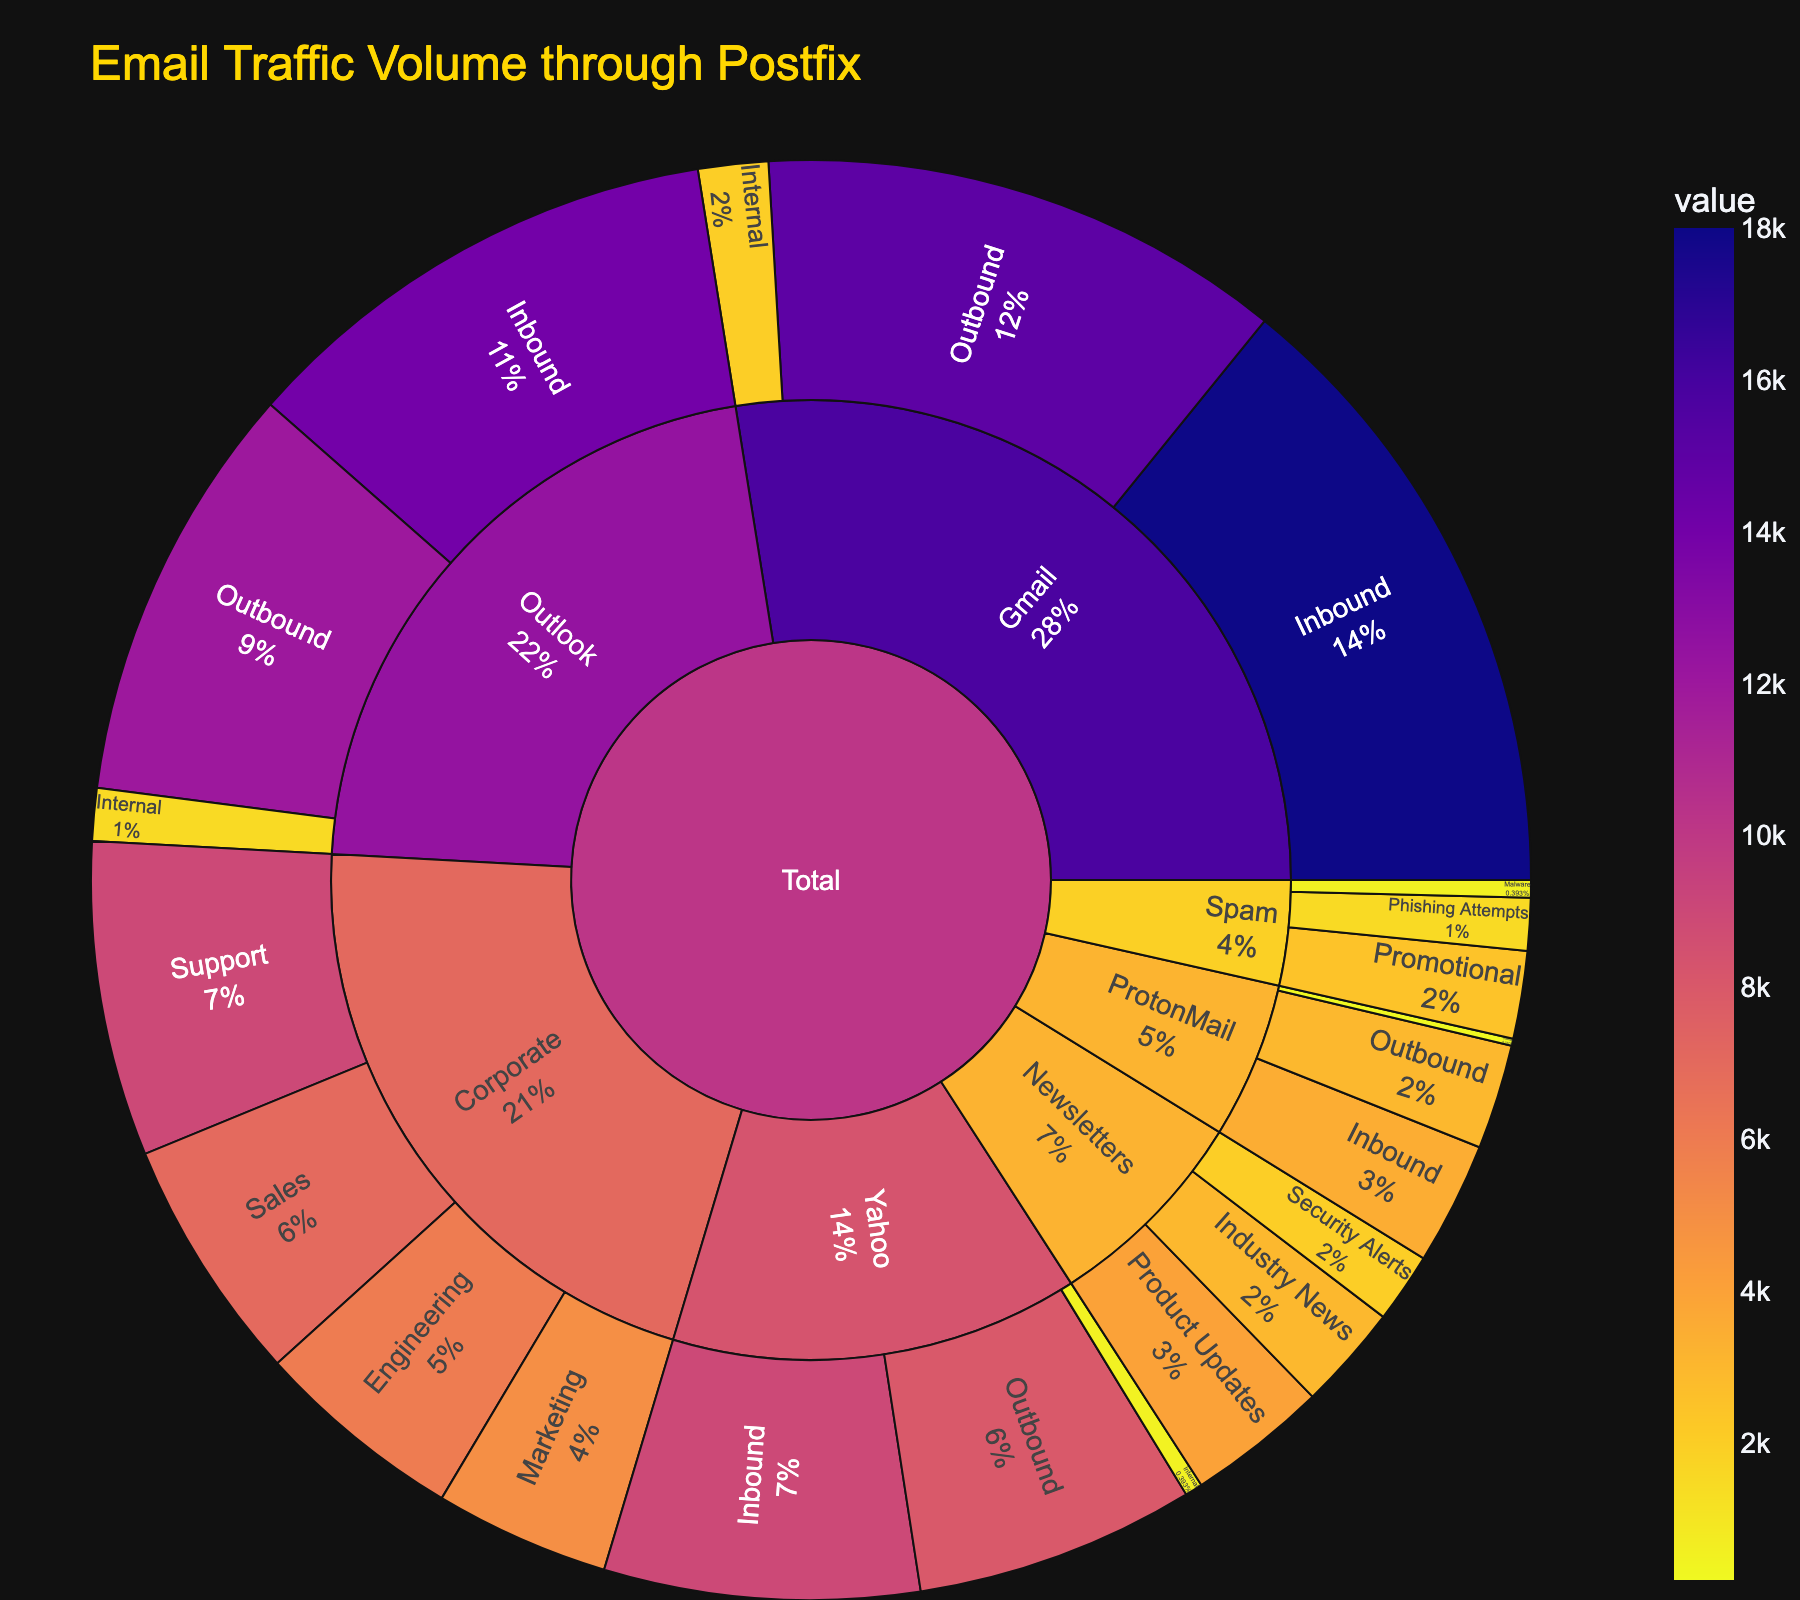How many emails were categorized under Newsletters? Find the values for each subcategory under Newsletters (Product Updates: 4000, Industry News: 3000, Security Alerts: 2000) and sum them: 4000 + 3000 + 2000
Answer: 9000 What percentage of the total email volume does the Corporate category represent? Calculate the total volume of Corporate emails (Marketing: 5000, Sales: 7000, Support: 9000, Engineering: 6000) which is 27000. Then sum up all values in the dataset to find the total volume, which is 130700. Compute the percentage: (27000/130700) * 100
Answer: ≈ 20.6% Which sender domain has the highest inbound email volume? Compare the inbound email volumes for each domain (Gmail: 18000, Outlook: 14000, Yahoo: 9000, ProtonMail: 3500) and identify the highest
Answer: Gmail What is the difference in the volume of outbound emails between Outlook and Yahoo? Subtract Yahoo's outbound volume (8000) from Outlook's outbound volume (12000): 12000 - 8000
Answer: 4000 How does the volume of promotional spam compare to phishing attempts? Compare the volumes of Promotional (2500) and Phishing Attempts (1500) under the Spam category
Answer: Promotional spam is greater What percentage of total emails are internal communications in Gmail? Find the value for Gmail internal communications (2000) and divide it by the total Gmail emails (15000 + 18000 + 2000 = 35000), then multiply by 100: (2000/35000) * 100
Answer: ≈ 5.7% Which individual subcategory has the smallest email volume? Identify the smallest value among all subcategories: ProtonMail Internal (200)
Answer: ProtonMail Internal How much larger is the email volume for Gmail inbound compared to Gmail internal? Subtract Gmail internal volume (2000) from Gmail inbound volume (18000): 18000 - 2000
Answer: 16000 What's the total volume of Spam emails? Sum the values for each Spam subcategory (Phishing Attempts: 1500, Promotional: 2500, Malware: 500): 1500 + 2500 + 500
Answer: 4500 